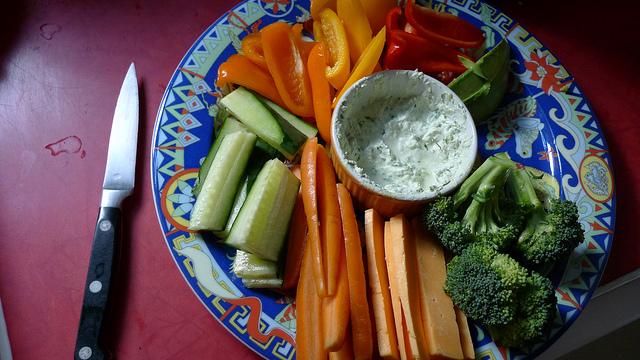Is there any cheese on the plate?
Write a very short answer. No. How many different types of vegetables are on the plate?
Answer briefly. 6. What vegetables are green?
Concise answer only. Broccoli. 